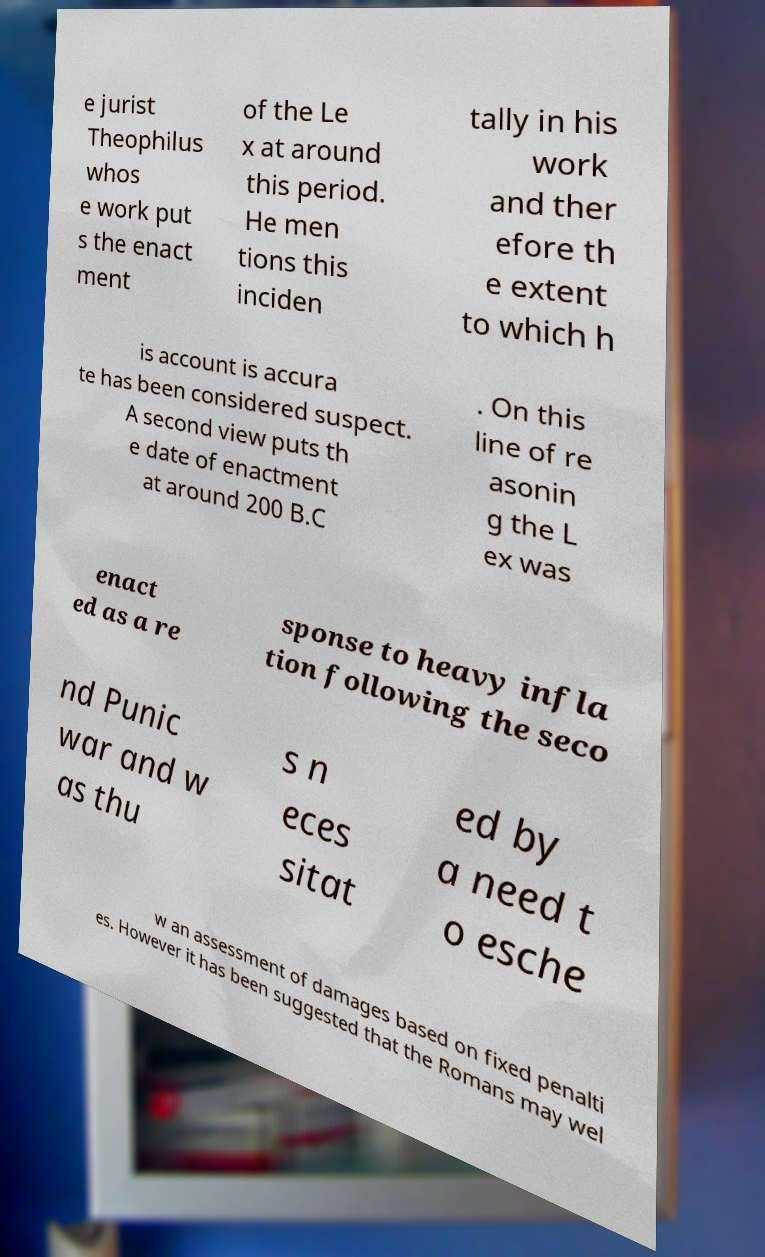Could you assist in decoding the text presented in this image and type it out clearly? e jurist Theophilus whos e work put s the enact ment of the Le x at around this period. He men tions this inciden tally in his work and ther efore th e extent to which h is account is accura te has been considered suspect. A second view puts th e date of enactment at around 200 B.C . On this line of re asonin g the L ex was enact ed as a re sponse to heavy infla tion following the seco nd Punic war and w as thu s n eces sitat ed by a need t o esche w an assessment of damages based on fixed penalti es. However it has been suggested that the Romans may wel 